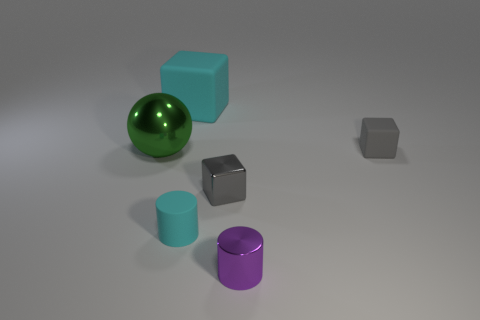Subtract all small gray cubes. How many cubes are left? 1 Subtract all gray cubes. How many cubes are left? 1 Subtract 2 cylinders. How many cylinders are left? 0 Add 2 large rubber cubes. How many objects exist? 8 Subtract all red balls. Subtract all brown cylinders. How many balls are left? 1 Add 1 small gray blocks. How many small gray blocks exist? 3 Subtract 0 green cylinders. How many objects are left? 6 Subtract all spheres. How many objects are left? 5 Subtract all yellow balls. How many cyan cylinders are left? 1 Subtract all large matte cubes. Subtract all big purple matte spheres. How many objects are left? 5 